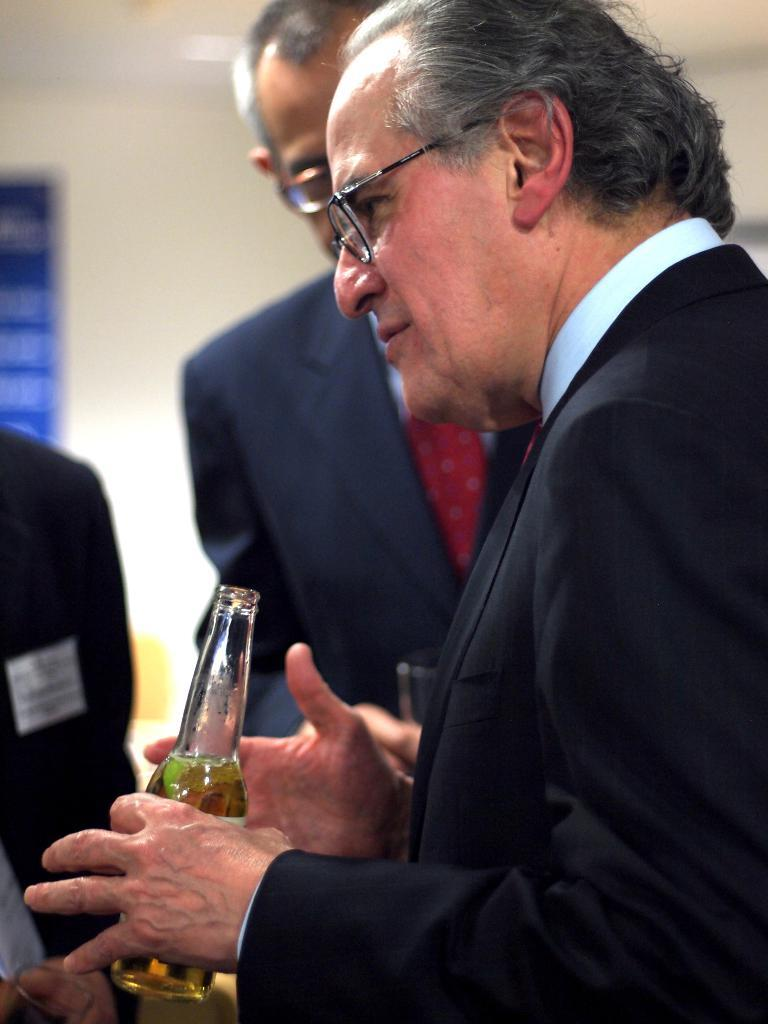Who is present in the image? There is a man in the image. What is the man holding in his hand? The man is holding a beer bottle in his hand. What is the man doing in the image? The man is speaking with other people. What type of horse is the man riding in the image? There is no horse present in the image; the man is standing and speaking with other people. 